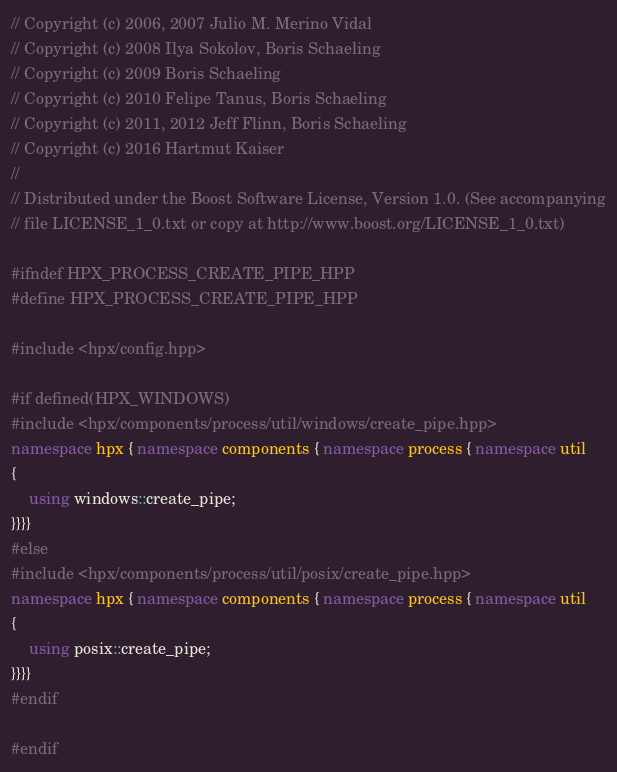Convert code to text. <code><loc_0><loc_0><loc_500><loc_500><_C++_>// Copyright (c) 2006, 2007 Julio M. Merino Vidal
// Copyright (c) 2008 Ilya Sokolov, Boris Schaeling
// Copyright (c) 2009 Boris Schaeling
// Copyright (c) 2010 Felipe Tanus, Boris Schaeling
// Copyright (c) 2011, 2012 Jeff Flinn, Boris Schaeling
// Copyright (c) 2016 Hartmut Kaiser
//
// Distributed under the Boost Software License, Version 1.0. (See accompanying
// file LICENSE_1_0.txt or copy at http://www.boost.org/LICENSE_1_0.txt)

#ifndef HPX_PROCESS_CREATE_PIPE_HPP
#define HPX_PROCESS_CREATE_PIPE_HPP

#include <hpx/config.hpp>

#if defined(HPX_WINDOWS)
#include <hpx/components/process/util/windows/create_pipe.hpp>
namespace hpx { namespace components { namespace process { namespace util
{
    using windows::create_pipe;
}}}}
#else
#include <hpx/components/process/util/posix/create_pipe.hpp>
namespace hpx { namespace components { namespace process { namespace util
{
    using posix::create_pipe;
}}}}
#endif

#endif
</code> 